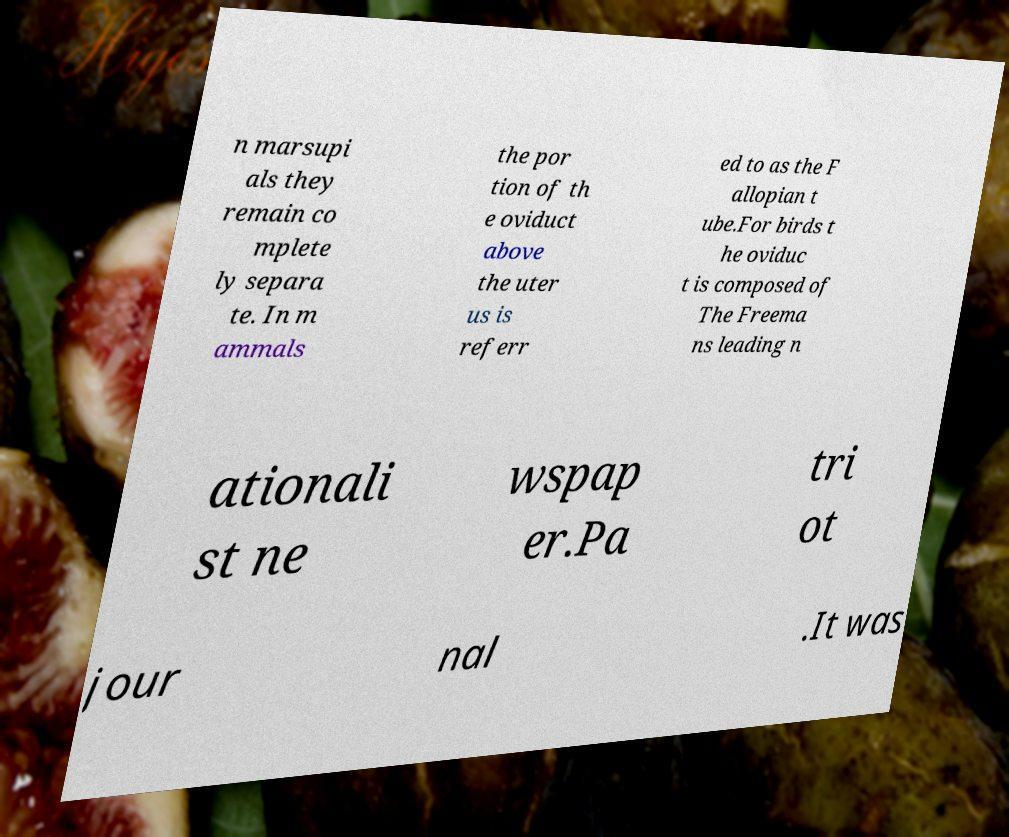Can you read and provide the text displayed in the image?This photo seems to have some interesting text. Can you extract and type it out for me? n marsupi als they remain co mplete ly separa te. In m ammals the por tion of th e oviduct above the uter us is referr ed to as the F allopian t ube.For birds t he oviduc t is composed of The Freema ns leading n ationali st ne wspap er.Pa tri ot jour nal .It was 